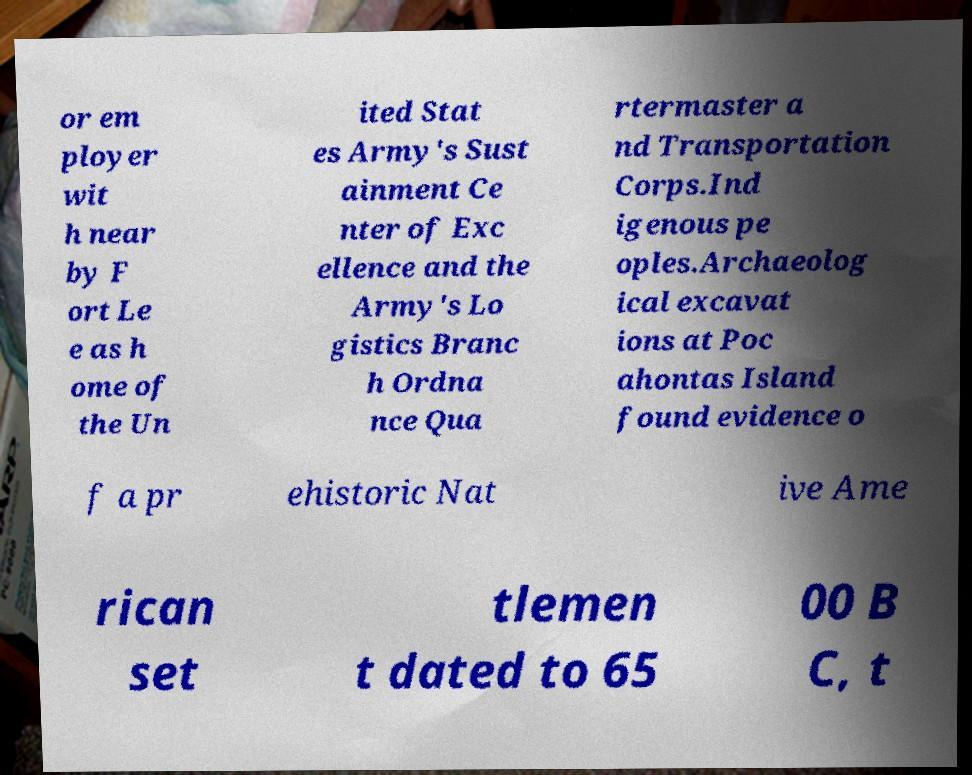For documentation purposes, I need the text within this image transcribed. Could you provide that? or em ployer wit h near by F ort Le e as h ome of the Un ited Stat es Army's Sust ainment Ce nter of Exc ellence and the Army's Lo gistics Branc h Ordna nce Qua rtermaster a nd Transportation Corps.Ind igenous pe oples.Archaeolog ical excavat ions at Poc ahontas Island found evidence o f a pr ehistoric Nat ive Ame rican set tlemen t dated to 65 00 B C, t 